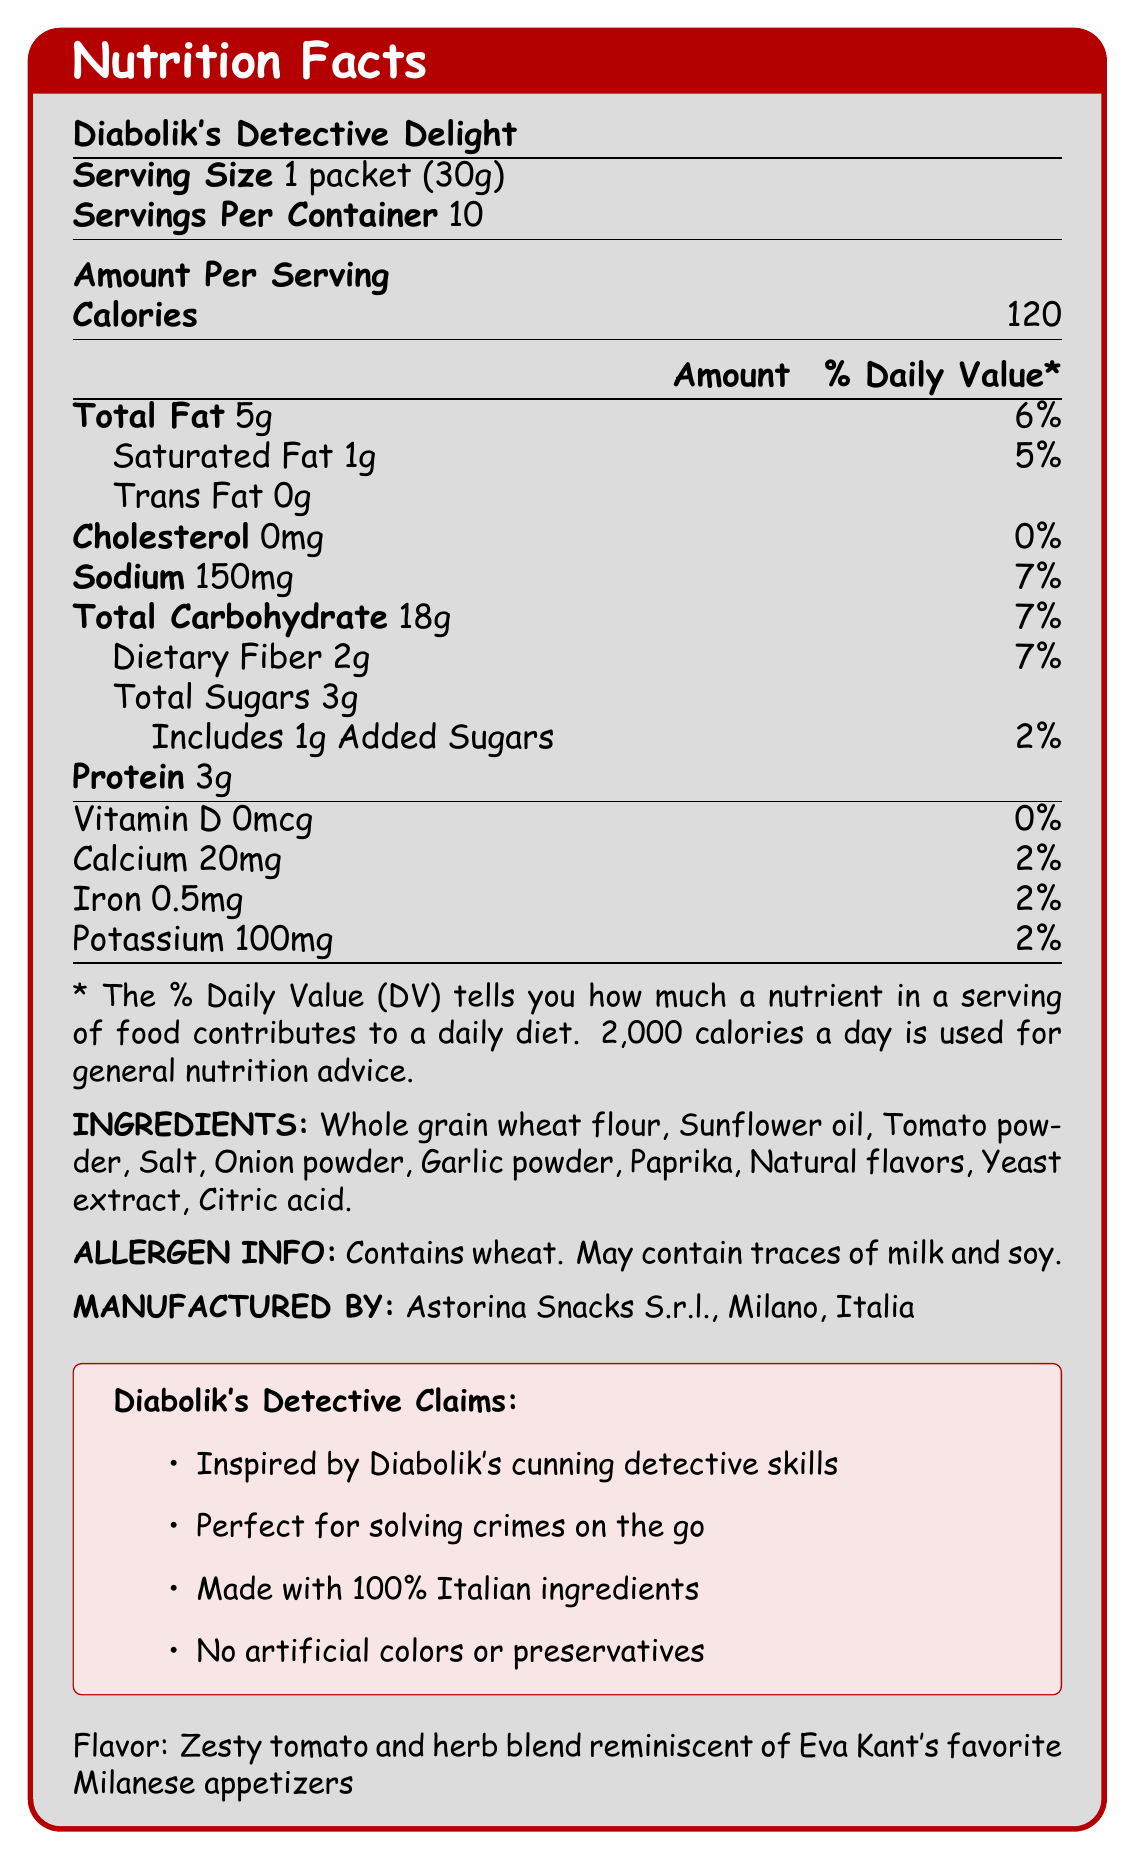what is the serving size? The serving size is explicitly mentioned at the beginning of the document as "Serving Size: 1 packet (30g)".
Answer: 1 packet (30g) how many calories are there in one serving? The document states "Calories: 120" under the section "Amount Per Serving".
Answer: 120 what is the total fat content per serving and its percentage of the daily value? The document lists "Total Fat: 5g" and provides the daily value as "6%".
Answer: 5g, 6% which vitamin has a 0% daily value in this product? The section detailing vitamins and minerals shows "Vitamin D 0mcg 0%".
Answer: Vitamin D what ingredients are used in Diabolik's Detective Delight? The ingredients are listed under the section titled "INGREDIENTS:".
Answer: Whole grain wheat flour, Sunflower oil, Tomato powder, Salt, Onion powder, Garlic powder, Paprika, Natural flavors, Yeast extract, Citric acid how much protein is in a single serving of this snack? The document specifies "Protein 3g" under the nutritional information.
Answer: 3g which of the following allergens is definitely present in Diabolik's Detective Delight? A. Soy B. Milk C. Wheat The allergen information states "Contains wheat. May contain traces of milk and soy.", indicating that wheat is definitely present.
Answer: C. Wheat what is the flavor description of this product? A. Spicy chili blend B. Zesty tomato and herb blend C. Sweet honey and oat blend The flavor description is provided at the end of the document as "Flavor: Zesty tomato and herb blend reminiscent of Eva Kant's favorite Milanese appetizers".
Answer: B. Zesty tomato and herb blend is the product made with artificial colors or preservatives? One of the marketing claims is "No artificial colors or preservatives."
Answer: No does this product contain any cholesterol? The nutritional information lists "Cholesterol 0mg 0%", indicating no cholesterol in the product.
Answer: No summarize the entire document's content The document is a detailed nutritional label for Diabolik's Detective Delight, providing essential nutritional facts, ingredients, and additional marketing information related to the product.
Answer: The document presents the Nutrition Facts and details for Diabolik's Detective Delight, a crime-solving snack inspired by the Diabolik series. It includes serving size, nutritional content per serving (like calories, fats, sodium, carbohydrates, sugars, and protein), vitamin and mineral content, ingredients, allergen information, manufacturer details, marketing claims, and flavor description. who is the manufacturer of Diabolik's Detective Delight? The manufacturer information is found under the section "MANUFACTURED BY: Astorina Snacks S.r.l., Milano, Italia".
Answer: Astorina Snacks S.r.l., Milano, Italia how much dietary fiber does a serving provide and what is its daily value percentage? The document lists "Dietary Fiber 2g" and "7%" as the daily value percentage.
Answer: 2g, 7% what is the total carbohydrate content in one serving? The nutritional information states "Total Carbohydrate 18g".
Answer: 18g how many servings are in one container of Diabolik's Detective Delight? The document specifies "Servings Per Container 10".
Answer: 10 what percentage of the daily value of calcium does a single serving of this snack provide? The document shows "Calcium 20mg 2%" under the vitamin and mineral information.
Answer: 2% who is Eva Kant? The document references Eva Kant in the flavor description, but does not provide any context or details about her.
Answer: Not enough information 